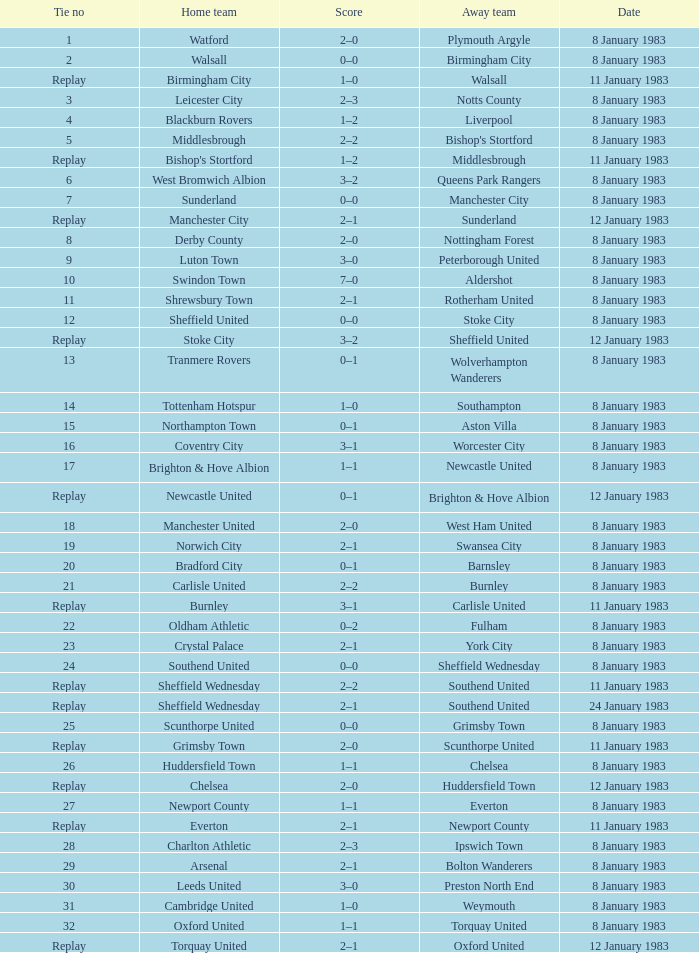Could you parse the entire table as a dict? {'header': ['Tie no', 'Home team', 'Score', 'Away team', 'Date'], 'rows': [['1', 'Watford', '2–0', 'Plymouth Argyle', '8 January 1983'], ['2', 'Walsall', '0–0', 'Birmingham City', '8 January 1983'], ['Replay', 'Birmingham City', '1–0', 'Walsall', '11 January 1983'], ['3', 'Leicester City', '2–3', 'Notts County', '8 January 1983'], ['4', 'Blackburn Rovers', '1–2', 'Liverpool', '8 January 1983'], ['5', 'Middlesbrough', '2–2', "Bishop's Stortford", '8 January 1983'], ['Replay', "Bishop's Stortford", '1–2', 'Middlesbrough', '11 January 1983'], ['6', 'West Bromwich Albion', '3–2', 'Queens Park Rangers', '8 January 1983'], ['7', 'Sunderland', '0–0', 'Manchester City', '8 January 1983'], ['Replay', 'Manchester City', '2–1', 'Sunderland', '12 January 1983'], ['8', 'Derby County', '2–0', 'Nottingham Forest', '8 January 1983'], ['9', 'Luton Town', '3–0', 'Peterborough United', '8 January 1983'], ['10', 'Swindon Town', '7–0', 'Aldershot', '8 January 1983'], ['11', 'Shrewsbury Town', '2–1', 'Rotherham United', '8 January 1983'], ['12', 'Sheffield United', '0–0', 'Stoke City', '8 January 1983'], ['Replay', 'Stoke City', '3–2', 'Sheffield United', '12 January 1983'], ['13', 'Tranmere Rovers', '0–1', 'Wolverhampton Wanderers', '8 January 1983'], ['14', 'Tottenham Hotspur', '1–0', 'Southampton', '8 January 1983'], ['15', 'Northampton Town', '0–1', 'Aston Villa', '8 January 1983'], ['16', 'Coventry City', '3–1', 'Worcester City', '8 January 1983'], ['17', 'Brighton & Hove Albion', '1–1', 'Newcastle United', '8 January 1983'], ['Replay', 'Newcastle United', '0–1', 'Brighton & Hove Albion', '12 January 1983'], ['18', 'Manchester United', '2–0', 'West Ham United', '8 January 1983'], ['19', 'Norwich City', '2–1', 'Swansea City', '8 January 1983'], ['20', 'Bradford City', '0–1', 'Barnsley', '8 January 1983'], ['21', 'Carlisle United', '2–2', 'Burnley', '8 January 1983'], ['Replay', 'Burnley', '3–1', 'Carlisle United', '11 January 1983'], ['22', 'Oldham Athletic', '0–2', 'Fulham', '8 January 1983'], ['23', 'Crystal Palace', '2–1', 'York City', '8 January 1983'], ['24', 'Southend United', '0–0', 'Sheffield Wednesday', '8 January 1983'], ['Replay', 'Sheffield Wednesday', '2–2', 'Southend United', '11 January 1983'], ['Replay', 'Sheffield Wednesday', '2–1', 'Southend United', '24 January 1983'], ['25', 'Scunthorpe United', '0–0', 'Grimsby Town', '8 January 1983'], ['Replay', 'Grimsby Town', '2–0', 'Scunthorpe United', '11 January 1983'], ['26', 'Huddersfield Town', '1–1', 'Chelsea', '8 January 1983'], ['Replay', 'Chelsea', '2–0', 'Huddersfield Town', '12 January 1983'], ['27', 'Newport County', '1–1', 'Everton', '8 January 1983'], ['Replay', 'Everton', '2–1', 'Newport County', '11 January 1983'], ['28', 'Charlton Athletic', '2–3', 'Ipswich Town', '8 January 1983'], ['29', 'Arsenal', '2–1', 'Bolton Wanderers', '8 January 1983'], ['30', 'Leeds United', '3–0', 'Preston North End', '8 January 1983'], ['31', 'Cambridge United', '1–0', 'Weymouth', '8 January 1983'], ['32', 'Oxford United', '1–1', 'Torquay United', '8 January 1983'], ['Replay', 'Torquay United', '2–1', 'Oxford United', '12 January 1983']]} What was the date of tie #26's play? 8 January 1983. 